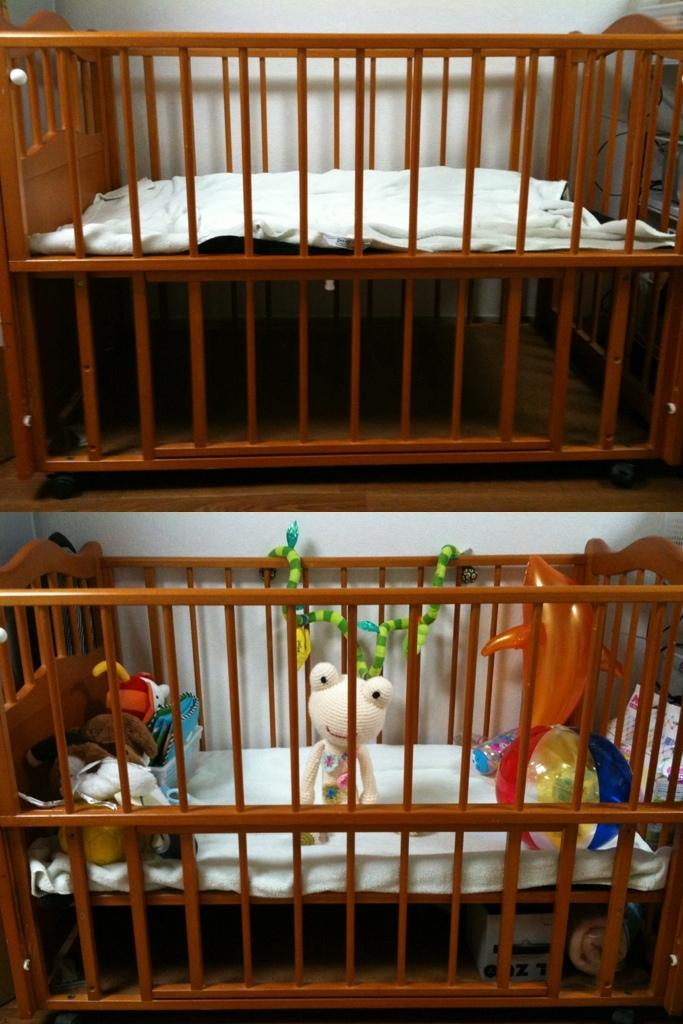What type of artwork is featured in the image? The image contains a collage. What is depicted in the collage? The collage includes a picture of a cradle bed. What can be seen inside the cradle bed? There is a group of toys placed in the cradle bed. How many waves can be seen in the image? There are no waves present in the image; it features a collage with a picture of a cradle bed and toys. What type of tray is visible in the image? There is no tray visible in the image. 